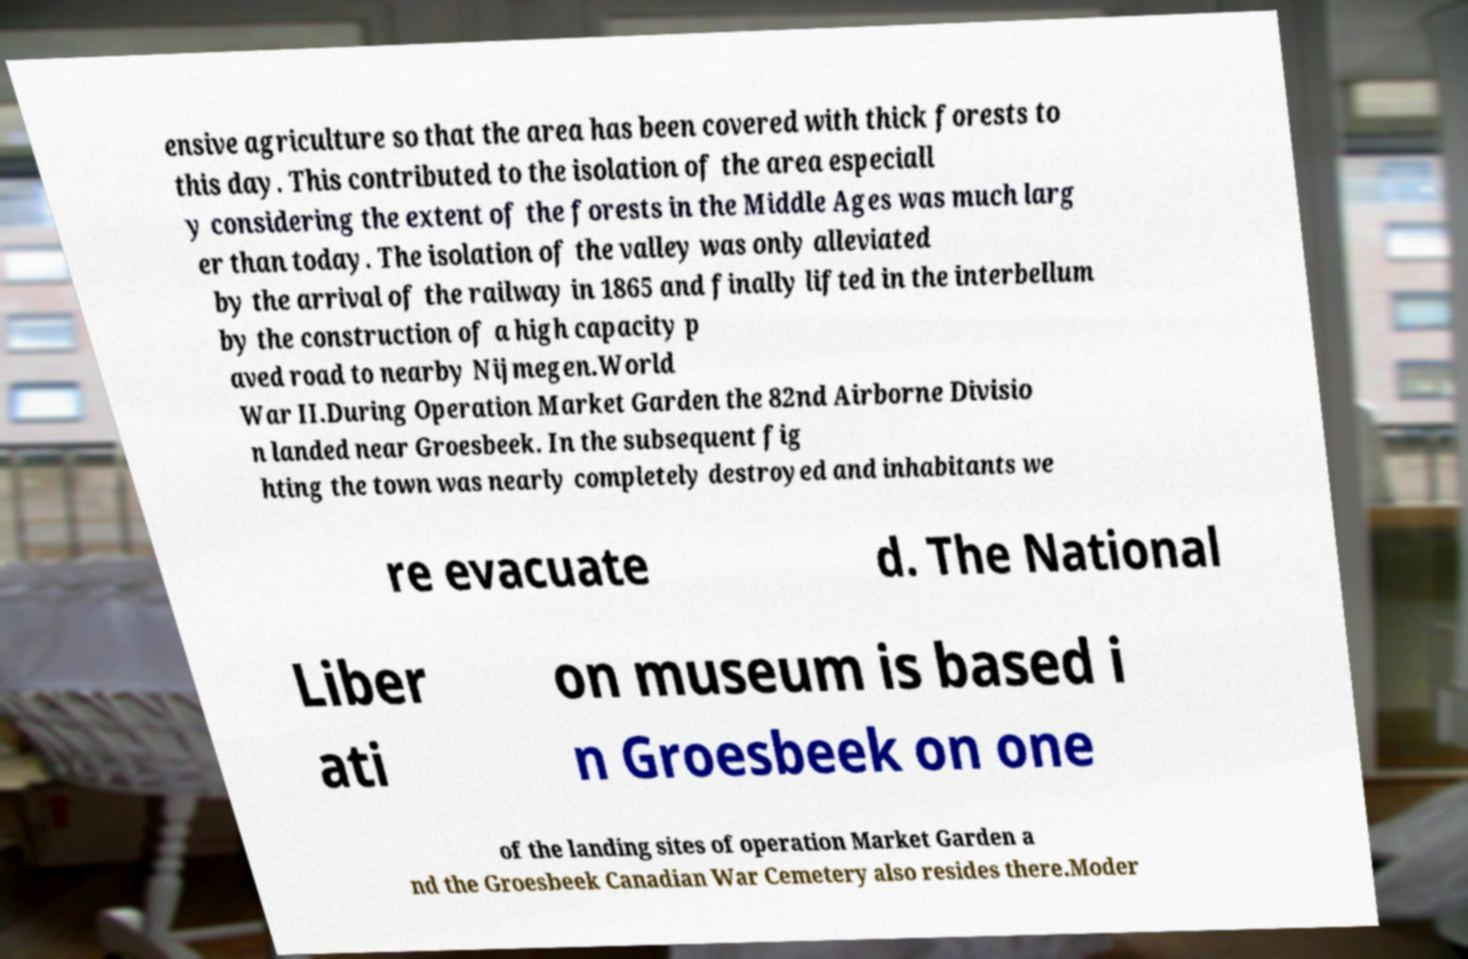Please identify and transcribe the text found in this image. ensive agriculture so that the area has been covered with thick forests to this day. This contributed to the isolation of the area especiall y considering the extent of the forests in the Middle Ages was much larg er than today. The isolation of the valley was only alleviated by the arrival of the railway in 1865 and finally lifted in the interbellum by the construction of a high capacity p aved road to nearby Nijmegen.World War II.During Operation Market Garden the 82nd Airborne Divisio n landed near Groesbeek. In the subsequent fig hting the town was nearly completely destroyed and inhabitants we re evacuate d. The National Liber ati on museum is based i n Groesbeek on one of the landing sites of operation Market Garden a nd the Groesbeek Canadian War Cemetery also resides there.Moder 